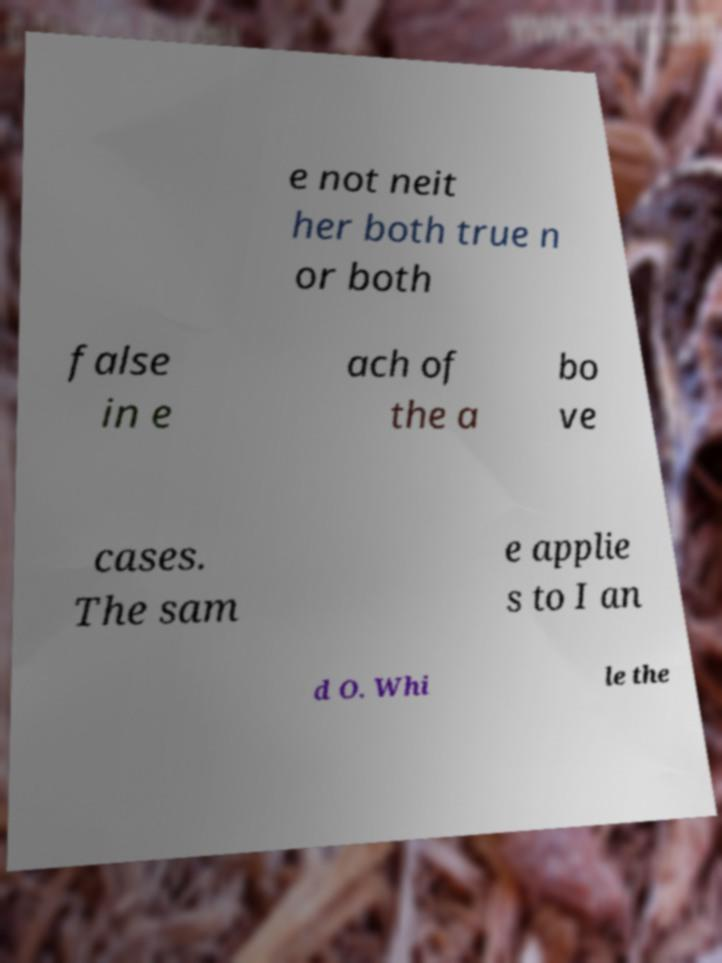Please read and relay the text visible in this image. What does it say? e not neit her both true n or both false in e ach of the a bo ve cases. The sam e applie s to I an d O. Whi le the 